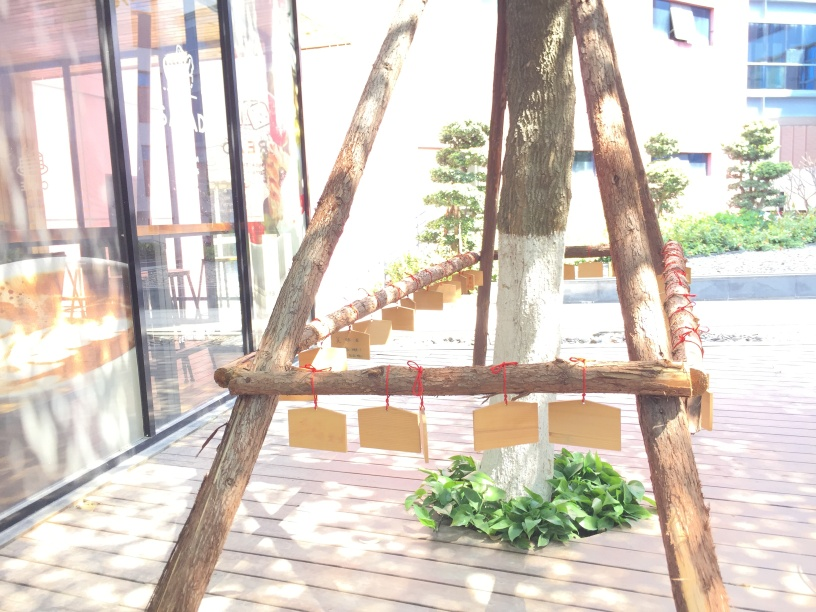Are there any quality issues with this image? The image appears to be overexposed with slightly washed out colors, which reduces the clarity and detail of the objects. There is also a noticeable glare on the right side that could be distracting. 